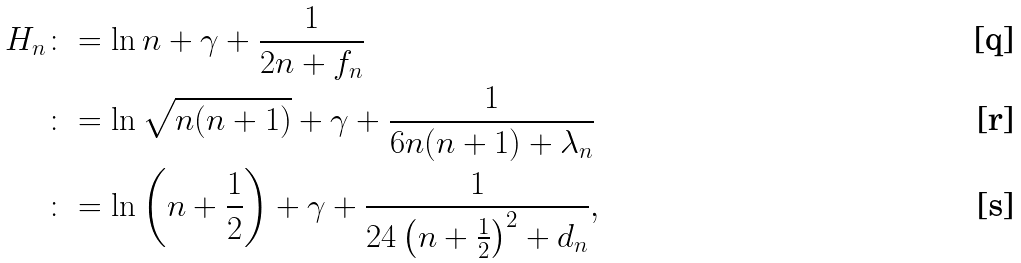<formula> <loc_0><loc_0><loc_500><loc_500>H _ { n } & \colon = \ln n + \gamma + \frac { 1 } { 2 n + f _ { n } } \\ & \colon = \ln \sqrt { n ( n + 1 ) } + \gamma + \frac { 1 } { 6 n ( n + 1 ) + \lambda _ { n } } \\ & \colon = \ln \left ( n + \frac { 1 } { 2 } \right ) + \gamma + \frac { 1 } { 2 4 \left ( n + \frac { 1 } { 2 } \right ) ^ { 2 } + d _ { n } } ,</formula> 